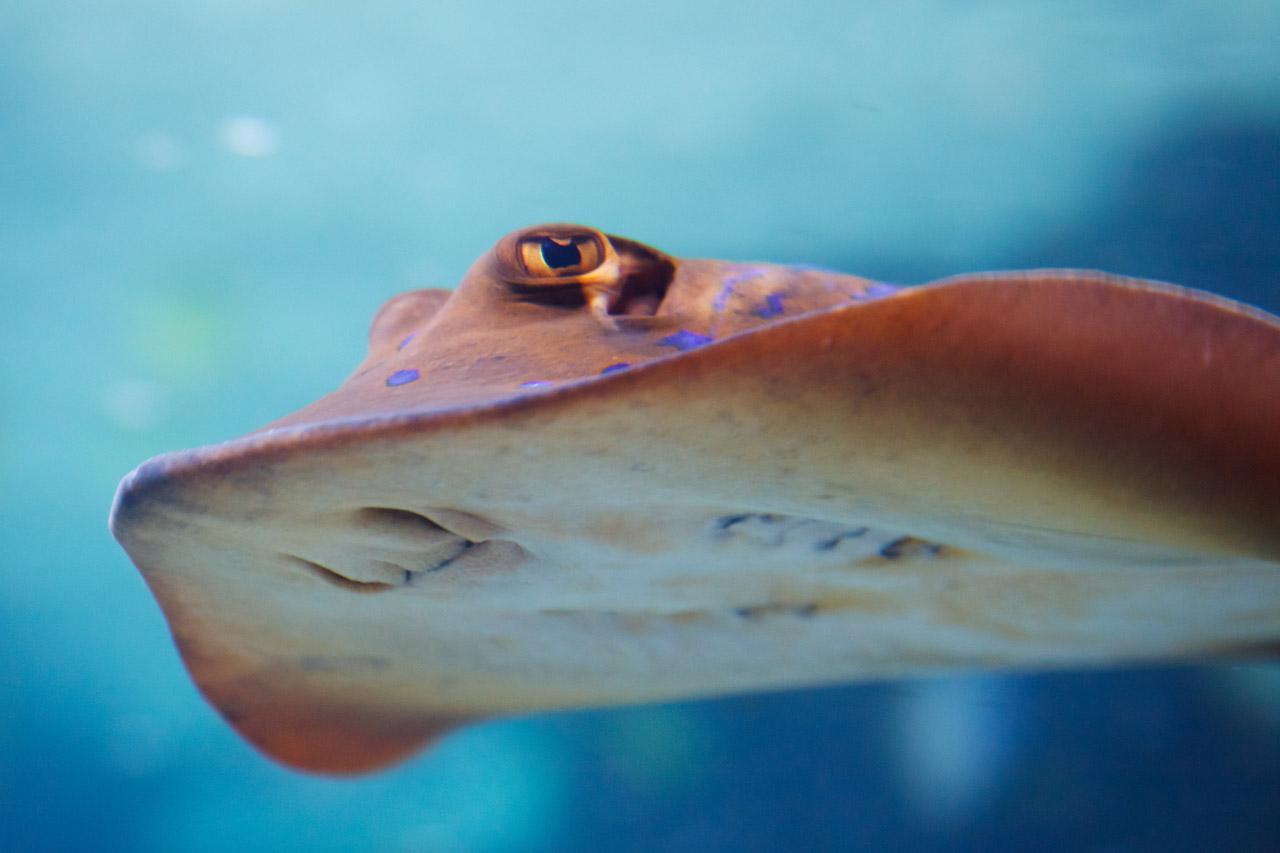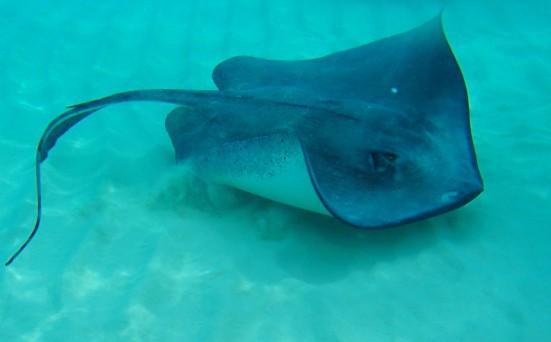The first image is the image on the left, the second image is the image on the right. Analyze the images presented: Is the assertion "The stingray on the right image is touching sand." valid? Answer yes or no. Yes. The first image is the image on the left, the second image is the image on the right. For the images shown, is this caption "One image shows the underbelly of a stingray in the foreground, and the other shows the top view of a dark blue stingray without distinctive spots." true? Answer yes or no. Yes. 